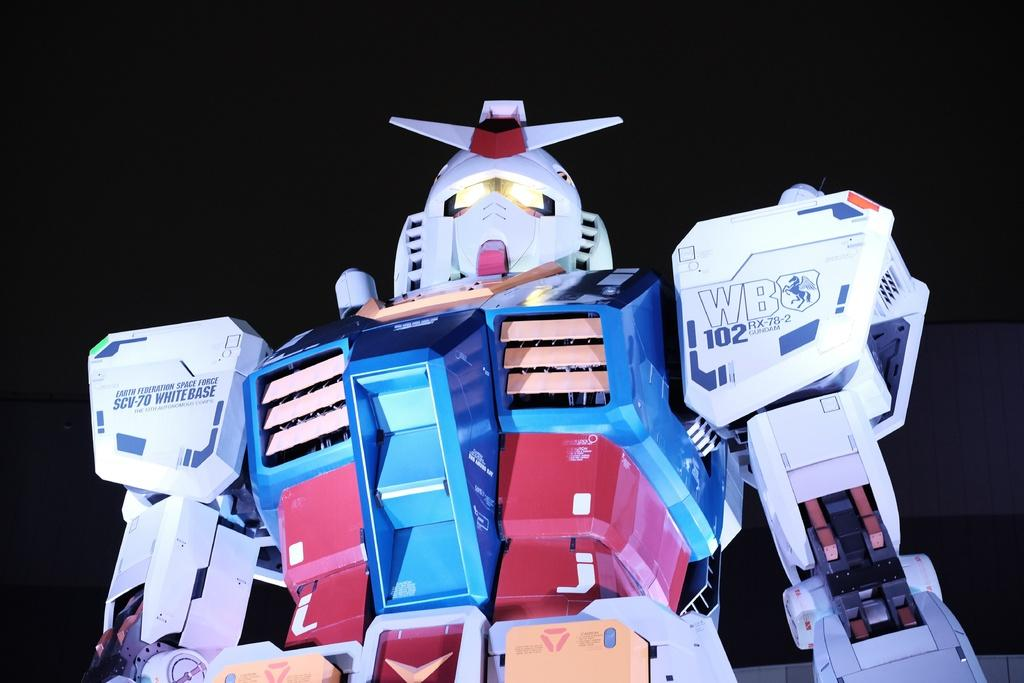What is the main subject of the image? The main subject of the image is a robot. What can be seen in the background of the image? The background of the image is black. What type of advice does the robot give to the governor in the image? There is no governor present in the image, and therefore no such interaction can be observed. What type of bait is the robot using to catch fish in the image? There is no fishing activity or bait present in the image; it features a robot with a black background. 